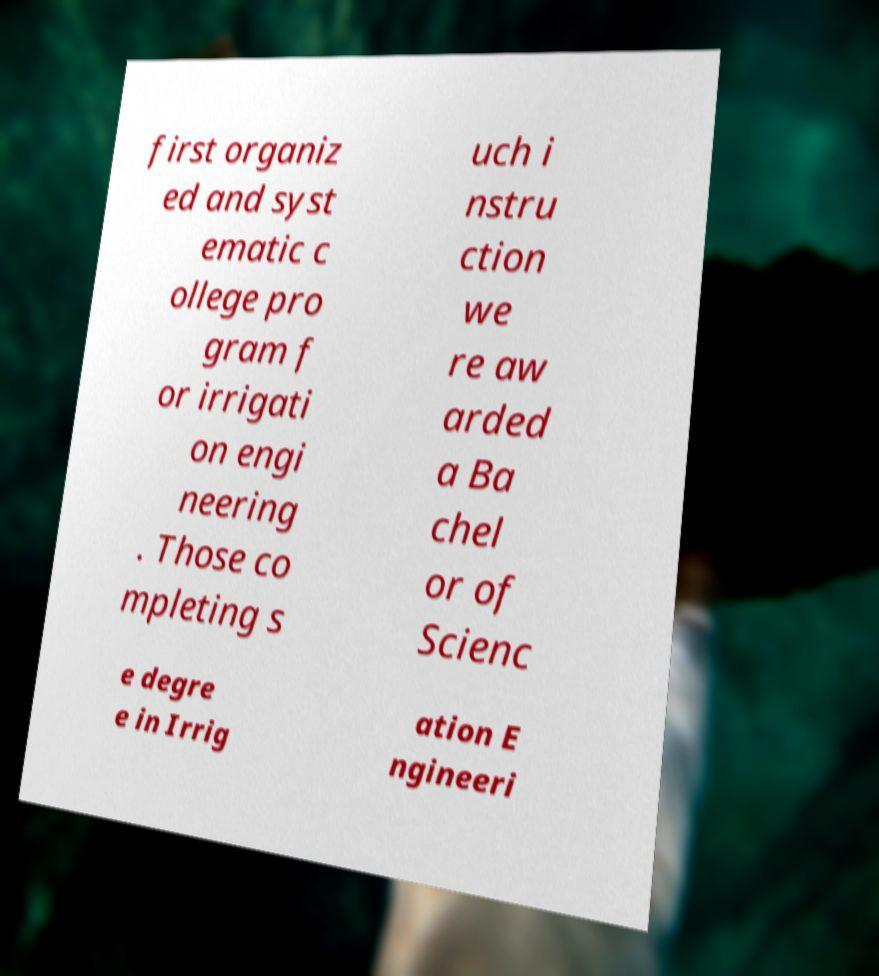I need the written content from this picture converted into text. Can you do that? first organiz ed and syst ematic c ollege pro gram f or irrigati on engi neering . Those co mpleting s uch i nstru ction we re aw arded a Ba chel or of Scienc e degre e in Irrig ation E ngineeri 